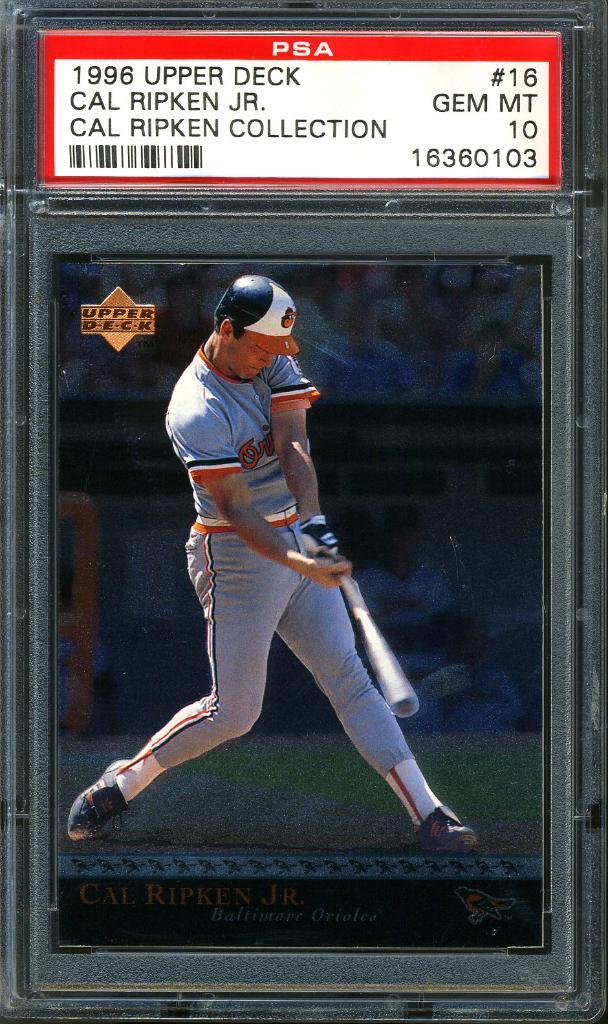<image>
Write a terse but informative summary of the picture. A Cal Ripkin Jr. baseball card is in a protective plastic sleeve. 